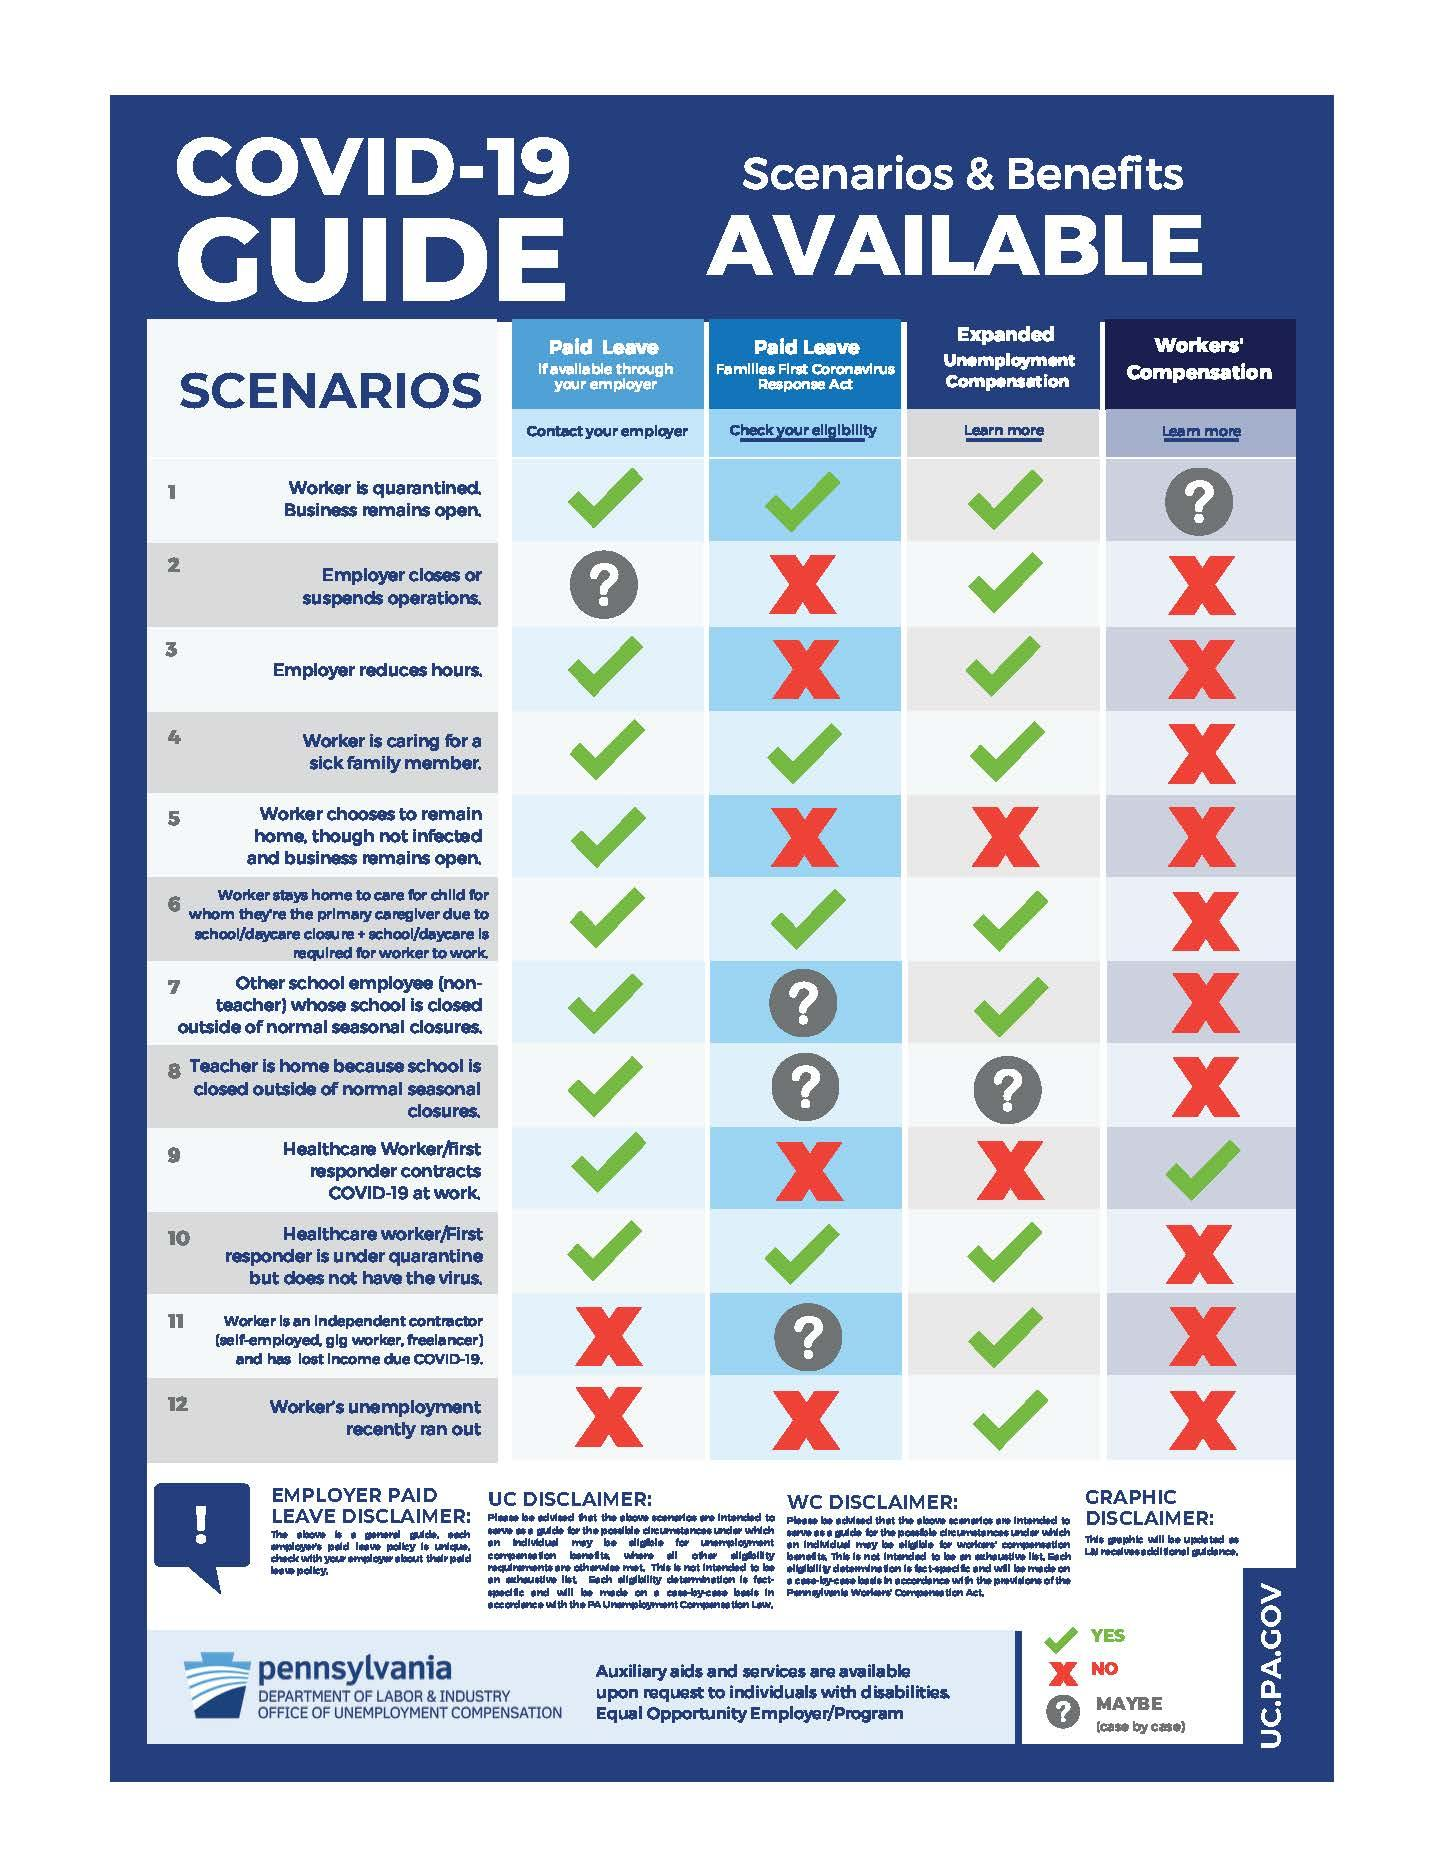List a handful of essential elements in this visual. There are 7 question mark icons in the infographic. There are 24 tick marks in total. There are a total of 20 cross marks. The color of the cross mark is red. The tick mark represents YES. 